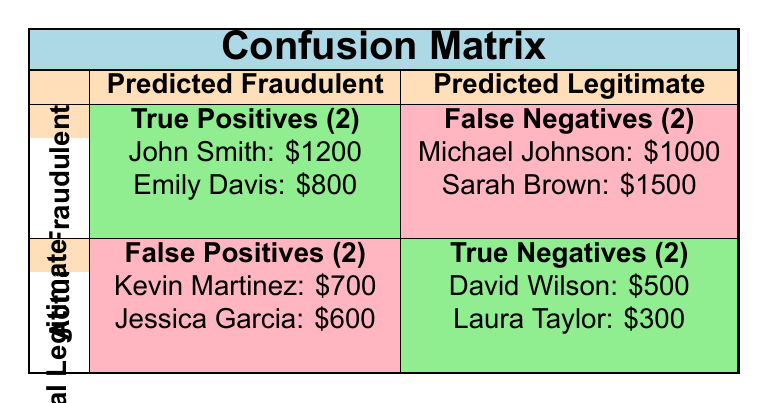What are the names of the claimants that were identified as true positives? The table indicates that there are two true positives. They are John Smith and Emily Davis.
Answer: John Smith, Emily Davis What amount was claimed by Sarah Brown? Sarah Brown is listed under false negatives with an amount claimed of 1500, as indicated in the table.
Answer: 1500 How many false positives were identified in the claims? The table shows there are 2 false positives, as indicated at the bottom left corner of the matrix.
Answer: 2 Which claimant had the highest amount claimed? To find this, we compare all amounts: 1200 (John Smith), 800 (Emily Davis), 1000 (Michael Johnson), 1500 (Sarah Brown), 700 (Kevin Martinez), 600 (Jessica Garcia), 500 (David Wilson), and 300 (Laura Taylor). The highest is 1500 (Sarah Brown).
Answer: 1500 Is it true that all true negatives were legitimate claims? Yes, all true negatives in the table (David Wilson and Laura Taylor) are marked as legitimate, confirming the claim.
Answer: Yes What is the total number of claims that were investigated? By reviewing the table, the investigated claims (true positives and false positives) total to four: John Smith, Emily Davis, Kevin Martinez, and Jessica Garcia.
Answer: 4 Which group contains the least number of claims? Both the true positives and false negatives groups contain 2 claims each, but the false positives and true negatives also contain 2 claims. Therefore, there is no group with a lesser number; they are all equal.
Answer: None (they are all equal) If all fraudulent claims were processed, what would be the implications based on false negatives? There are 2 false negatives (Michael Johnson and Sarah Brown) who were actually fraudulent but marked as legitimate. If processed as fraudulent, the total would be affected by both the financial loss and trust in the system.
Answer: Implications include financial losses and trust issues What is the difference in the amount claimed between the highest and lowest claimants in the true positive group? The highest claimed amount in true positives is 1200 (John Smith) and the lowest is 800 (Emily Davis). The difference is 1200 - 800 = 400.
Answer: 400 